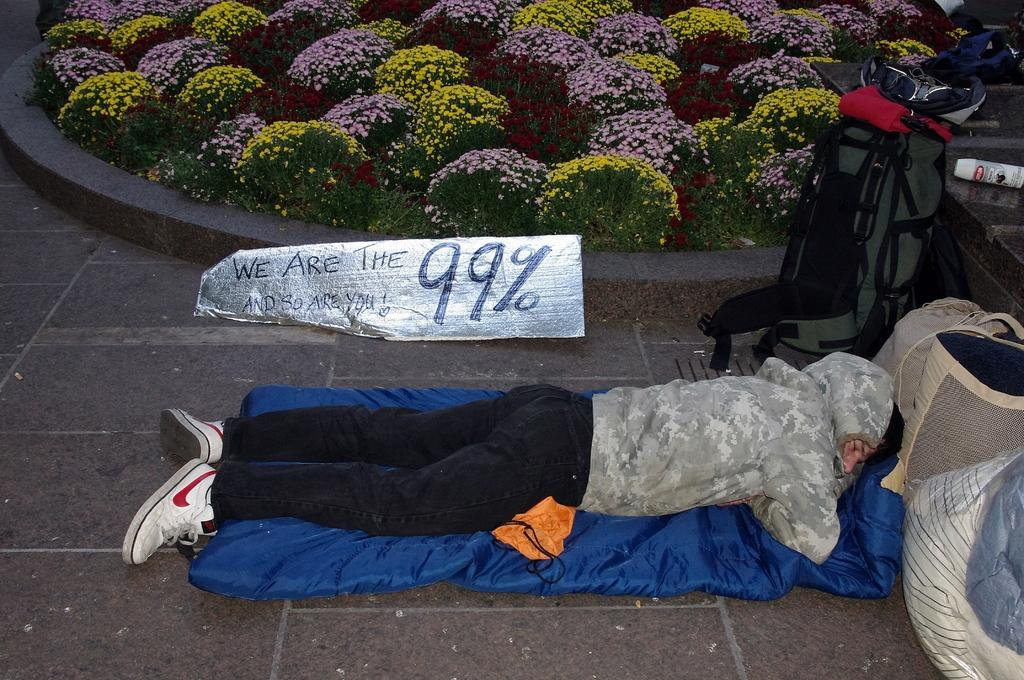What is the person in the image doing? There is a person sleeping on the bed in the image. What is located near the person's head? The person has luggage near their head. What type of plants can be seen in the image? There are flower plants in the image. What is wrapped in aluminium foil with a note in the image? There is a note wrapped in aluminium foil in the image. What type of rod can be seen supporting the bed in the image? There is no rod supporting the bed in the image; it is not mentioned in the provided facts. 